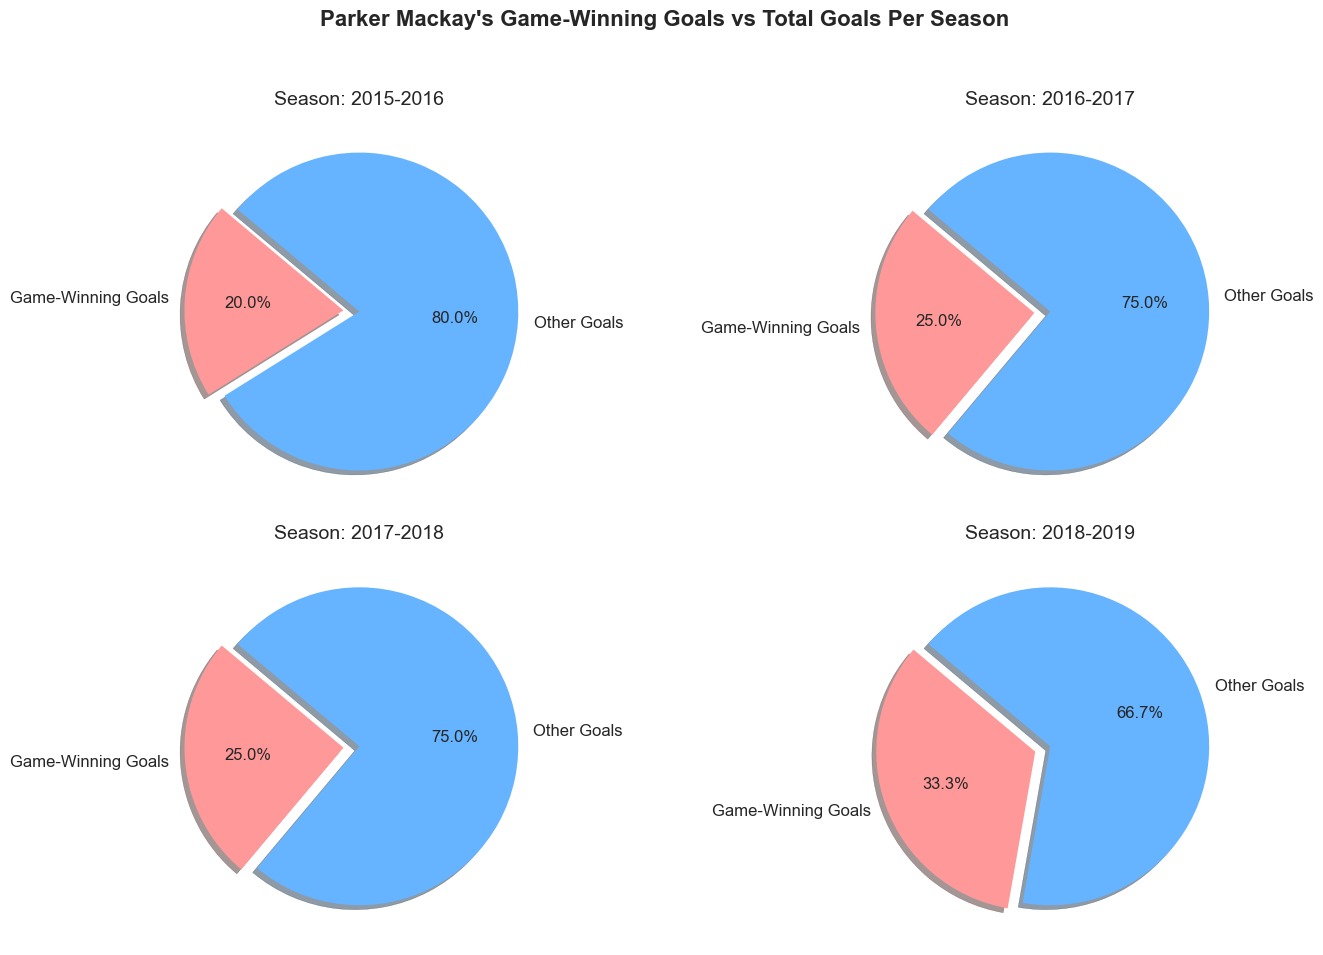Which season had the highest number of game-winning goals? The slice of the pie chart representing game-winning goals is largest for the season 2018-2019.
Answer: 2018-2019 What percentage of total goals were game-winning goals in the 2016-2017 season? For the 2016-2017 season, the pie chart shows the game-winning goals slice as 25% (3 out of 12 goals). This is confirmed by noting the label showing 25% next to the red slice for that season.
Answer: 25% Which season showed the highest proportion of other goals in comparison to game-winning goals? By observing the pie charts, the 2015-2016 season shows the highest proportion of other goals compared to game-winning goals, as the "Other Goals" slice appears larger.
Answer: 2015-2016 What is the total number of game-winning goals across all seasons? Summing up the game-winning goals from each season: 2 + 3 + 4 + 6 equals 15.
Answer: 15 How does the 2017-2018 season compare to the 2018-2019 season in terms of game-winning goals? The 2017-2018 season has 4 game-winning goals (25%), while the 2018-2019 season has 6 game-winning goals (33.33%), indicating that the 2018-2019 season had more game-winning goals both in absolute and percentage terms.
Answer: 2018-2019 had more In which season did Parker Mackay have the most balanced ratio between game-winning and other goals? The pie charts for 2018-2019 and 2017-2018 both look relatively balanced, but the most balanced is the 2018-2019 season where game-winning goals (33.33%) make up one-third.
Answer: 2018-2019 What is the total number of goals scored in the 2018-2019 season? Referring to the pie chart's title and the legend, we see 18 total goals in the 2018-2019 season.
Answer: 18 What percentage of Parker Mackay’s total goals for all seasons were game-winning goals? Sum of total goals is 56, and sum of game-winning goals is 15. Percentage is (15/56) * 100 = 26.79%.
Answer: 26.79% 